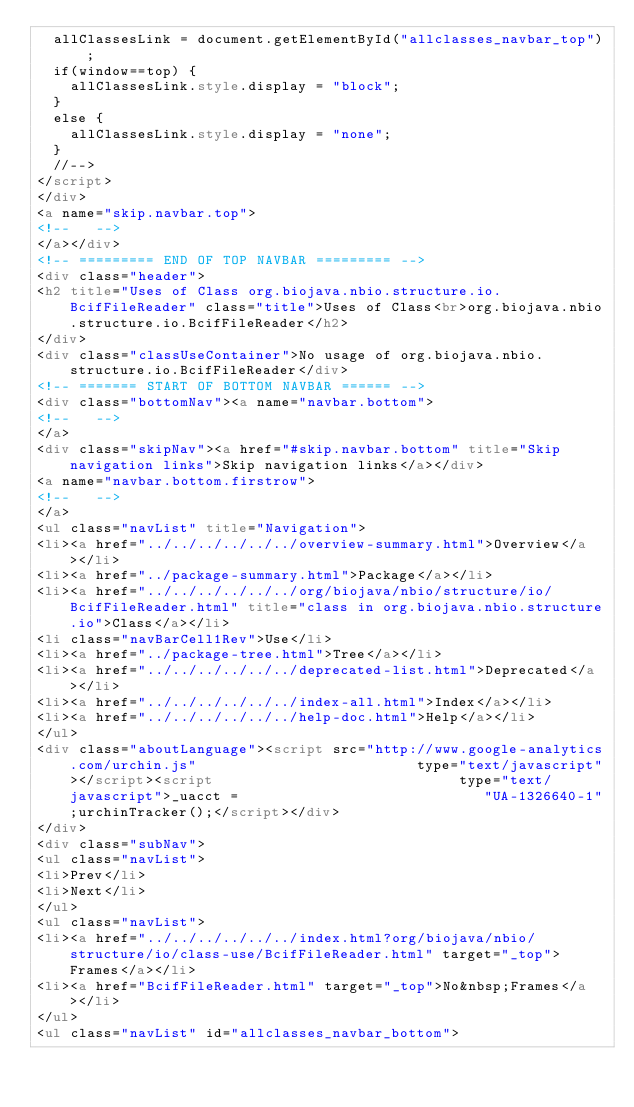<code> <loc_0><loc_0><loc_500><loc_500><_HTML_>  allClassesLink = document.getElementById("allclasses_navbar_top");
  if(window==top) {
    allClassesLink.style.display = "block";
  }
  else {
    allClassesLink.style.display = "none";
  }
  //-->
</script>
</div>
<a name="skip.navbar.top">
<!--   -->
</a></div>
<!-- ========= END OF TOP NAVBAR ========= -->
<div class="header">
<h2 title="Uses of Class org.biojava.nbio.structure.io.BcifFileReader" class="title">Uses of Class<br>org.biojava.nbio.structure.io.BcifFileReader</h2>
</div>
<div class="classUseContainer">No usage of org.biojava.nbio.structure.io.BcifFileReader</div>
<!-- ======= START OF BOTTOM NAVBAR ====== -->
<div class="bottomNav"><a name="navbar.bottom">
<!--   -->
</a>
<div class="skipNav"><a href="#skip.navbar.bottom" title="Skip navigation links">Skip navigation links</a></div>
<a name="navbar.bottom.firstrow">
<!--   -->
</a>
<ul class="navList" title="Navigation">
<li><a href="../../../../../../overview-summary.html">Overview</a></li>
<li><a href="../package-summary.html">Package</a></li>
<li><a href="../../../../../../org/biojava/nbio/structure/io/BcifFileReader.html" title="class in org.biojava.nbio.structure.io">Class</a></li>
<li class="navBarCell1Rev">Use</li>
<li><a href="../package-tree.html">Tree</a></li>
<li><a href="../../../../../../deprecated-list.html">Deprecated</a></li>
<li><a href="../../../../../../index-all.html">Index</a></li>
<li><a href="../../../../../../help-doc.html">Help</a></li>
</ul>
<div class="aboutLanguage"><script src="http://www.google-analytics.com/urchin.js" 							type="text/javascript"></script><script 							type="text/javascript">_uacct = 							"UA-1326640-1";urchinTracker();</script></div>
</div>
<div class="subNav">
<ul class="navList">
<li>Prev</li>
<li>Next</li>
</ul>
<ul class="navList">
<li><a href="../../../../../../index.html?org/biojava/nbio/structure/io/class-use/BcifFileReader.html" target="_top">Frames</a></li>
<li><a href="BcifFileReader.html" target="_top">No&nbsp;Frames</a></li>
</ul>
<ul class="navList" id="allclasses_navbar_bottom"></code> 